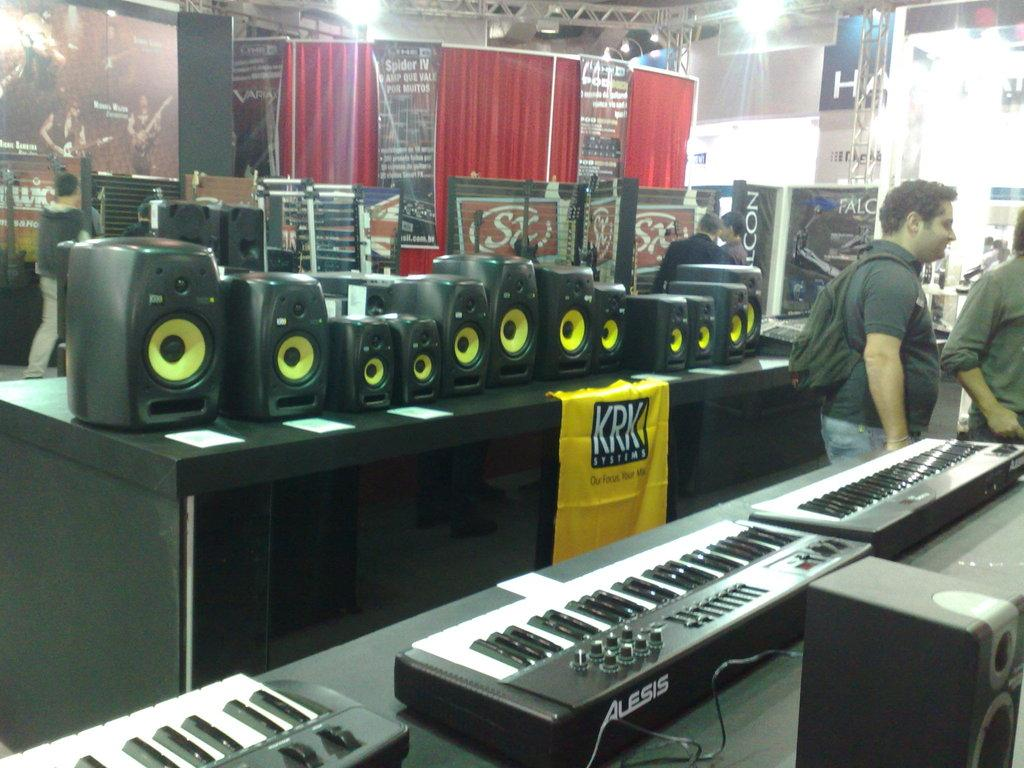What can be seen in the image involving people? There are people standing in the image. What is on the table in the image? There are speakers on a table in the image. What type of establishment is depicted in the image? There are casinos in the image. Can you describe the cushion that the stranger is sitting on in the image? There is no stranger or cushion present in the image. 